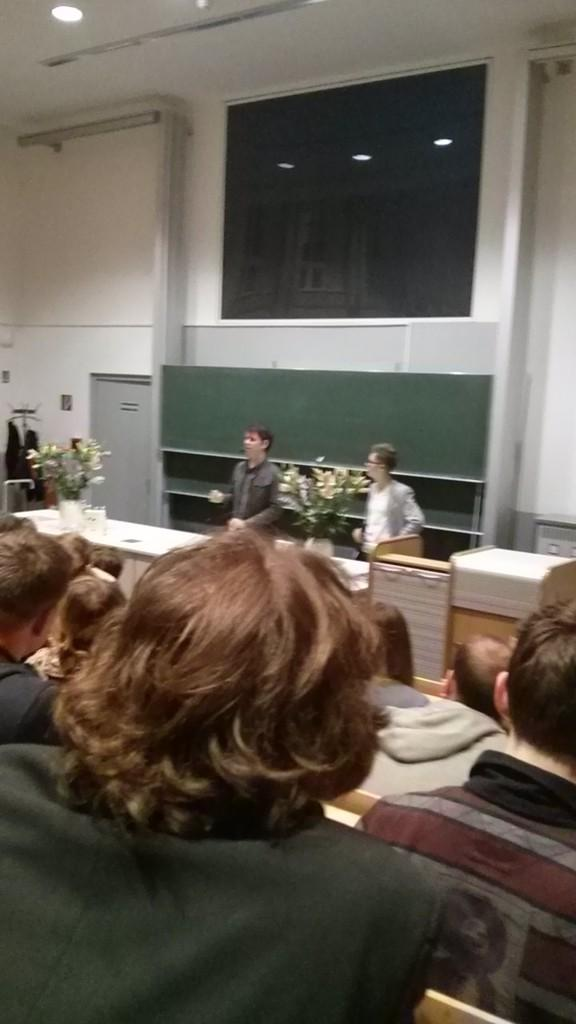How many people are standing in the image? There are two persons standing in the image. What is in front of the standing persons? There is a table in front of the standing persons. What can be seen on the table? The table has flower vases on it, and there are other objects on the table as well. What are the people sitting in front of the standing persons doing? The people sitting in front of the standing persons are not described in the facts, so we cannot determine their actions from the image. What type of tramp can be seen jumping over the table in the image? There is no tramp present in the image, and therefore no such activity can be observed. 